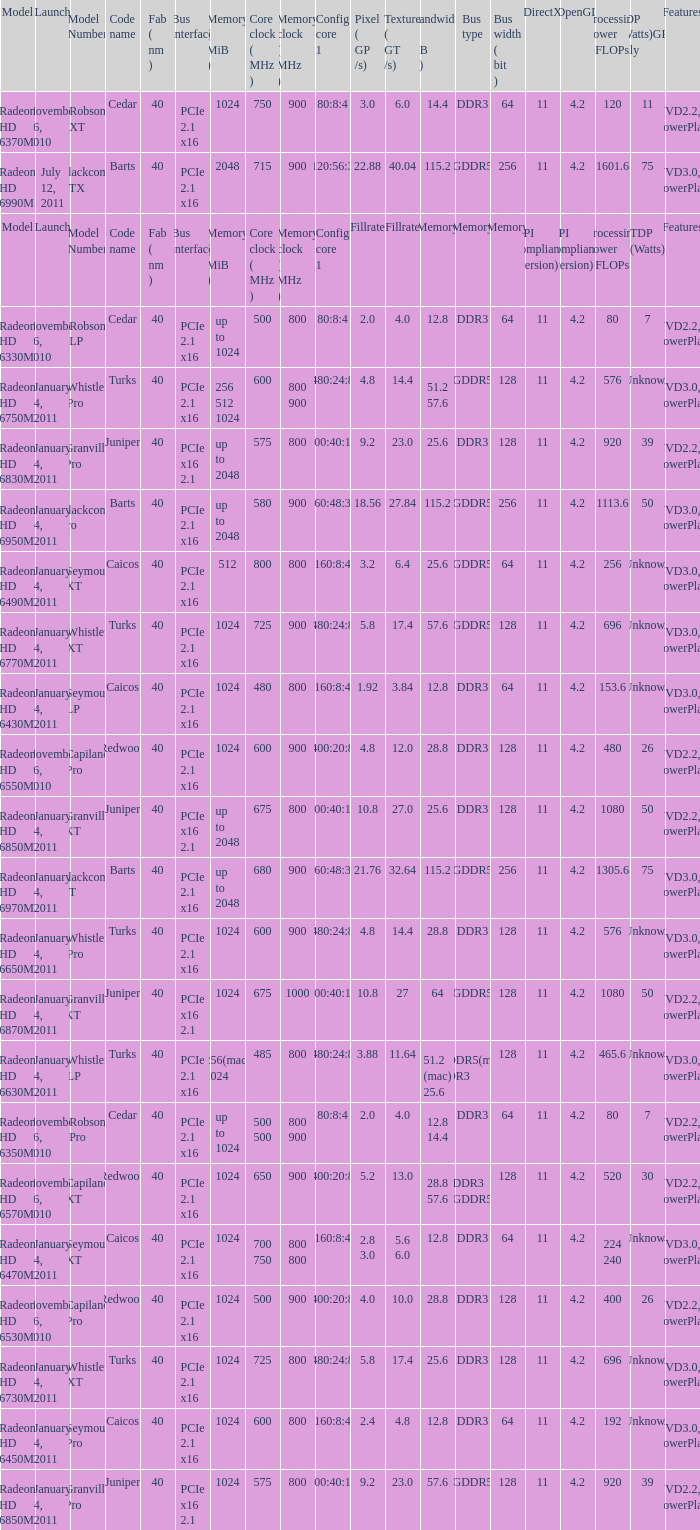What is the value for congi core 1 if the code name is Redwood and core clock(mhz) is 500? 400:20:8. 